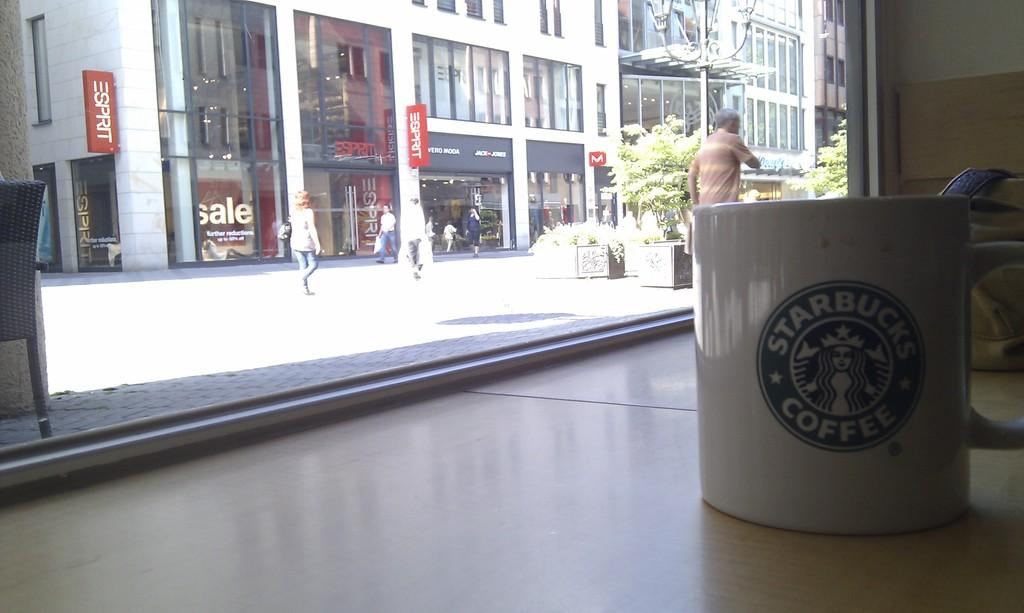<image>
Provide a brief description of the given image. An Esprit store is across the street from this Starbucks. 